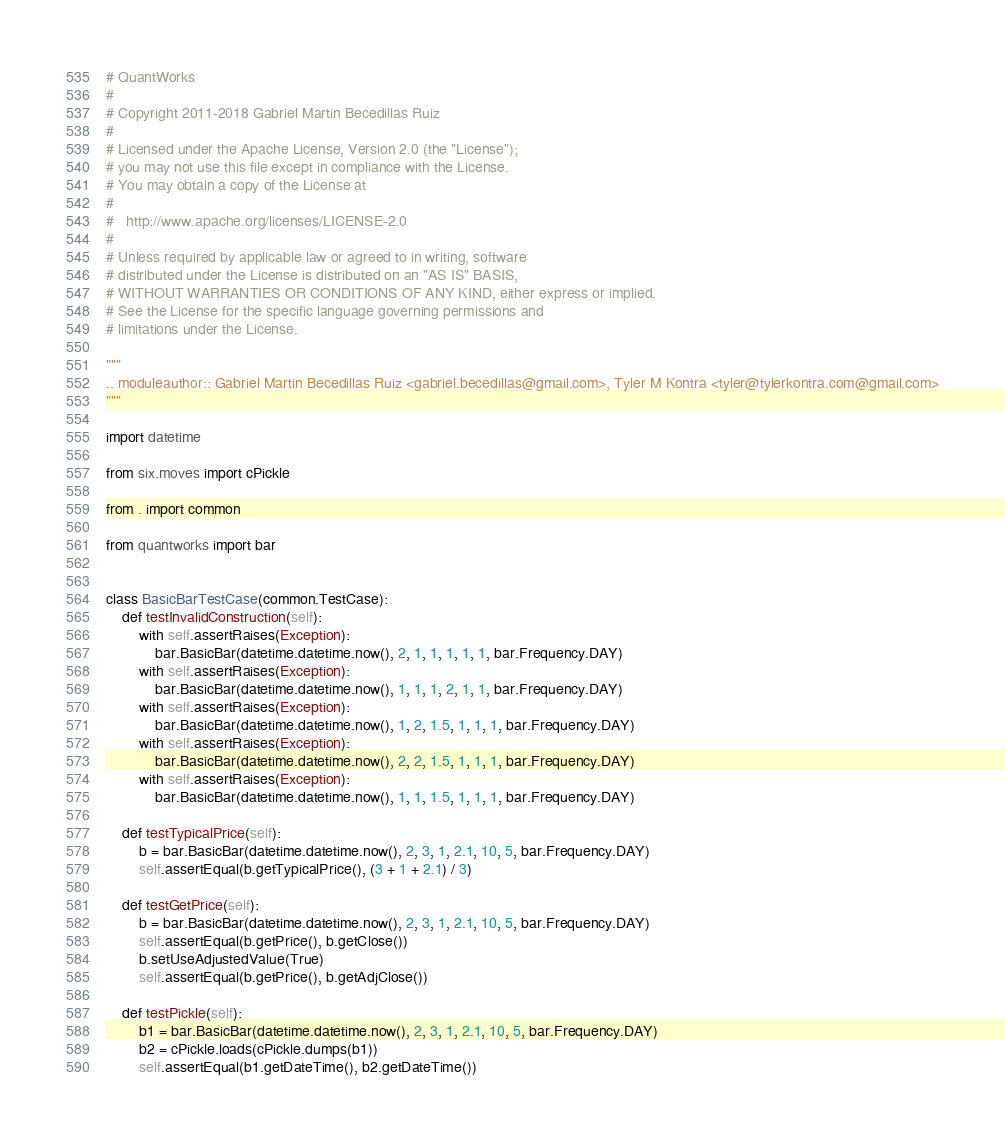Convert code to text. <code><loc_0><loc_0><loc_500><loc_500><_Python_># QuantWorks
#
# Copyright 2011-2018 Gabriel Martin Becedillas Ruiz
#
# Licensed under the Apache License, Version 2.0 (the "License");
# you may not use this file except in compliance with the License.
# You may obtain a copy of the License at
#
#   http://www.apache.org/licenses/LICENSE-2.0
#
# Unless required by applicable law or agreed to in writing, software
# distributed under the License is distributed on an "AS IS" BASIS,
# WITHOUT WARRANTIES OR CONDITIONS OF ANY KIND, either express or implied.
# See the License for the specific language governing permissions and
# limitations under the License.

"""
.. moduleauthor:: Gabriel Martin Becedillas Ruiz <gabriel.becedillas@gmail.com>, Tyler M Kontra <tyler@tylerkontra.com@gmail.com>
"""

import datetime

from six.moves import cPickle

from . import common

from quantworks import bar


class BasicBarTestCase(common.TestCase):
    def testInvalidConstruction(self):
        with self.assertRaises(Exception):
            bar.BasicBar(datetime.datetime.now(), 2, 1, 1, 1, 1, 1, bar.Frequency.DAY)
        with self.assertRaises(Exception):
            bar.BasicBar(datetime.datetime.now(), 1, 1, 1, 2, 1, 1, bar.Frequency.DAY)
        with self.assertRaises(Exception):
            bar.BasicBar(datetime.datetime.now(), 1, 2, 1.5, 1, 1, 1, bar.Frequency.DAY)
        with self.assertRaises(Exception):
            bar.BasicBar(datetime.datetime.now(), 2, 2, 1.5, 1, 1, 1, bar.Frequency.DAY)
        with self.assertRaises(Exception):
            bar.BasicBar(datetime.datetime.now(), 1, 1, 1.5, 1, 1, 1, bar.Frequency.DAY)

    def testTypicalPrice(self):
        b = bar.BasicBar(datetime.datetime.now(), 2, 3, 1, 2.1, 10, 5, bar.Frequency.DAY)
        self.assertEqual(b.getTypicalPrice(), (3 + 1 + 2.1) / 3)

    def testGetPrice(self):
        b = bar.BasicBar(datetime.datetime.now(), 2, 3, 1, 2.1, 10, 5, bar.Frequency.DAY)
        self.assertEqual(b.getPrice(), b.getClose())
        b.setUseAdjustedValue(True)
        self.assertEqual(b.getPrice(), b.getAdjClose())

    def testPickle(self):
        b1 = bar.BasicBar(datetime.datetime.now(), 2, 3, 1, 2.1, 10, 5, bar.Frequency.DAY)
        b2 = cPickle.loads(cPickle.dumps(b1))
        self.assertEqual(b1.getDateTime(), b2.getDateTime())</code> 